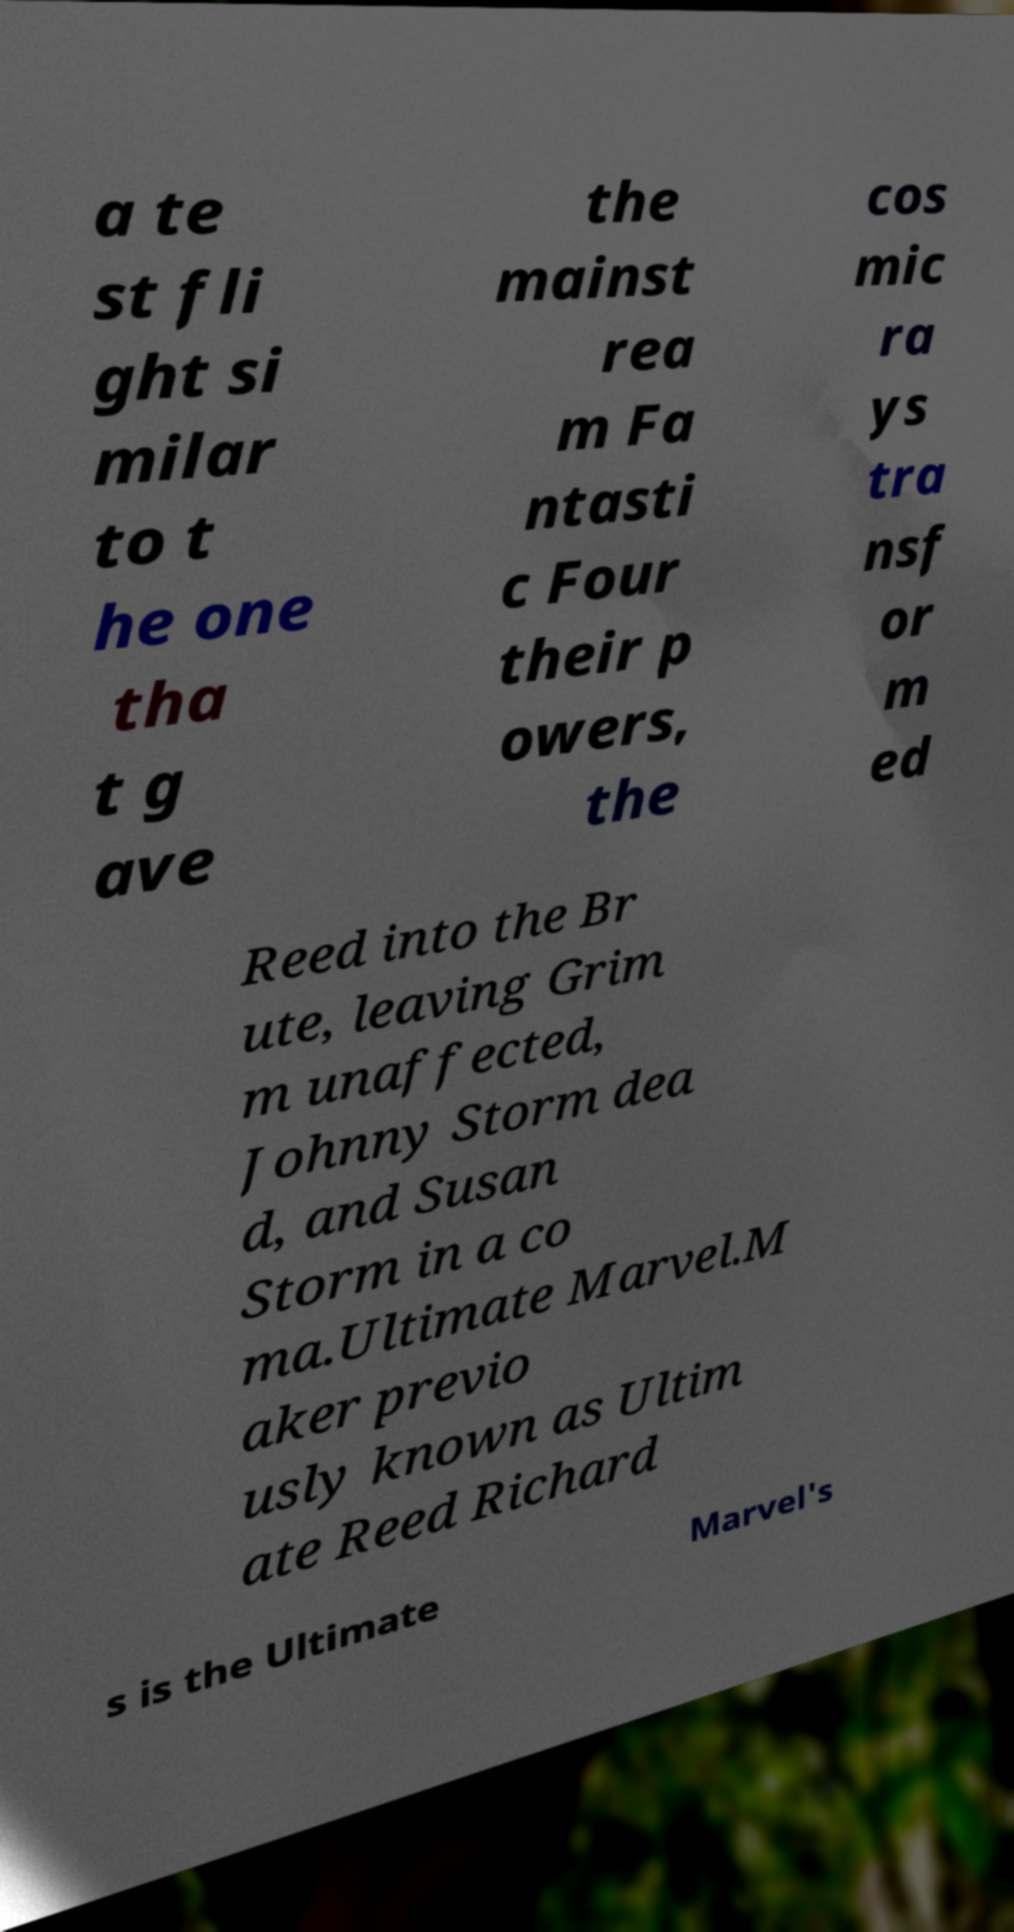There's text embedded in this image that I need extracted. Can you transcribe it verbatim? a te st fli ght si milar to t he one tha t g ave the mainst rea m Fa ntasti c Four their p owers, the cos mic ra ys tra nsf or m ed Reed into the Br ute, leaving Grim m unaffected, Johnny Storm dea d, and Susan Storm in a co ma.Ultimate Marvel.M aker previo usly known as Ultim ate Reed Richard s is the Ultimate Marvel's 